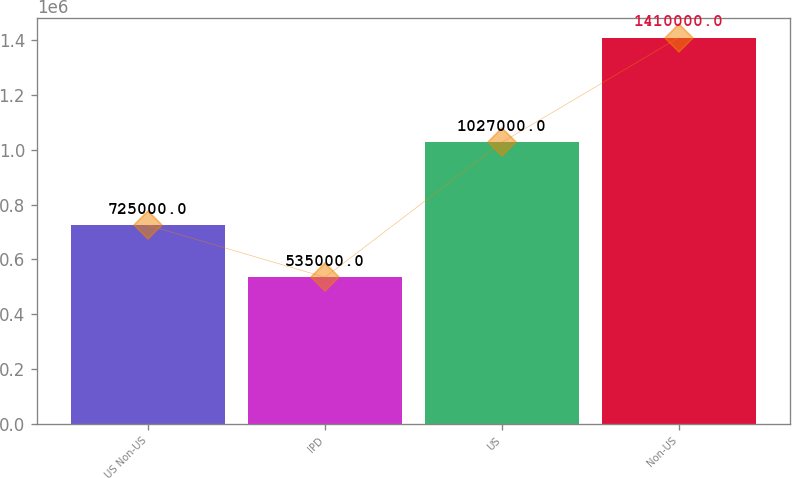<chart> <loc_0><loc_0><loc_500><loc_500><bar_chart><fcel>US Non-US<fcel>IPD<fcel>US<fcel>Non-US<nl><fcel>725000<fcel>535000<fcel>1.027e+06<fcel>1.41e+06<nl></chart> 